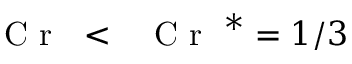<formula> <loc_0><loc_0><loc_500><loc_500>{ C r < { C r } ^ { * } = 1 / 3</formula> 